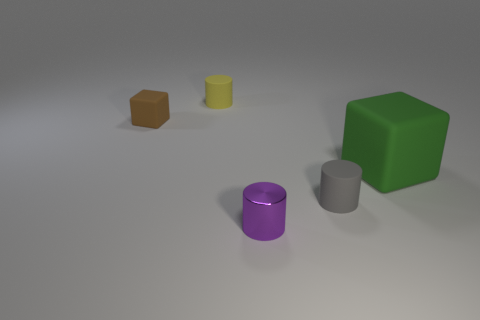Subtract all small gray matte cylinders. How many cylinders are left? 2 Add 2 gray cylinders. How many objects exist? 7 Subtract all blocks. How many objects are left? 3 Subtract all cyan cylinders. Subtract all green spheres. How many cylinders are left? 3 Add 3 rubber cubes. How many rubber cubes exist? 5 Subtract 0 purple cubes. How many objects are left? 5 Subtract all brown cubes. Subtract all small metal objects. How many objects are left? 3 Add 1 objects. How many objects are left? 6 